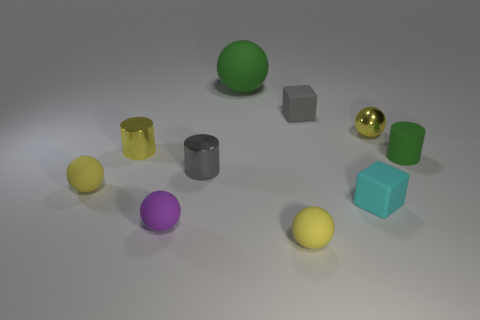Subtract all yellow spheres. How many were subtracted if there are1yellow spheres left? 2 Subtract all blue cubes. How many yellow spheres are left? 3 Subtract all blue spheres. Subtract all green cylinders. How many spheres are left? 5 Subtract all cylinders. How many objects are left? 7 Add 7 small shiny balls. How many small shiny balls are left? 8 Add 2 tiny balls. How many tiny balls exist? 6 Subtract 1 green spheres. How many objects are left? 9 Subtract all rubber cubes. Subtract all yellow cylinders. How many objects are left? 7 